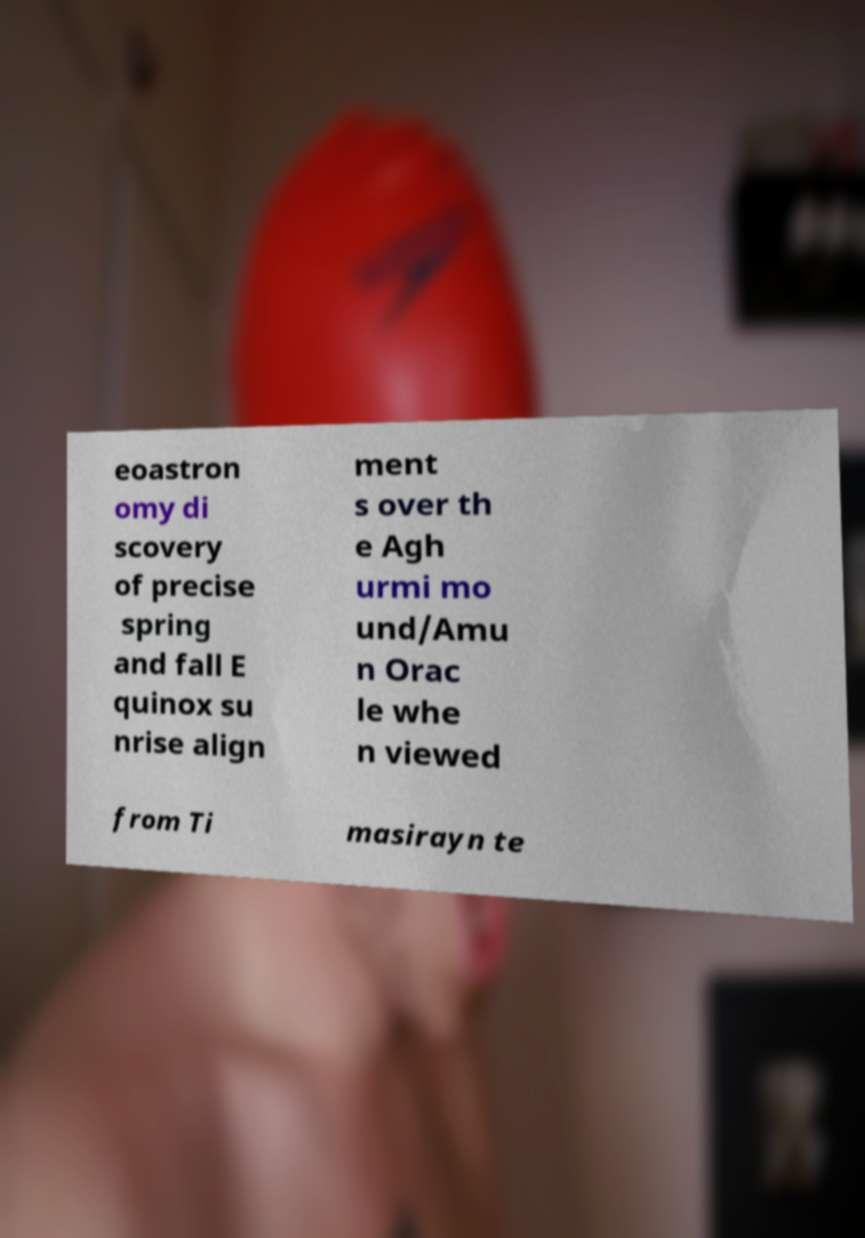Could you extract and type out the text from this image? eoastron omy di scovery of precise spring and fall E quinox su nrise align ment s over th e Agh urmi mo und/Amu n Orac le whe n viewed from Ti masirayn te 